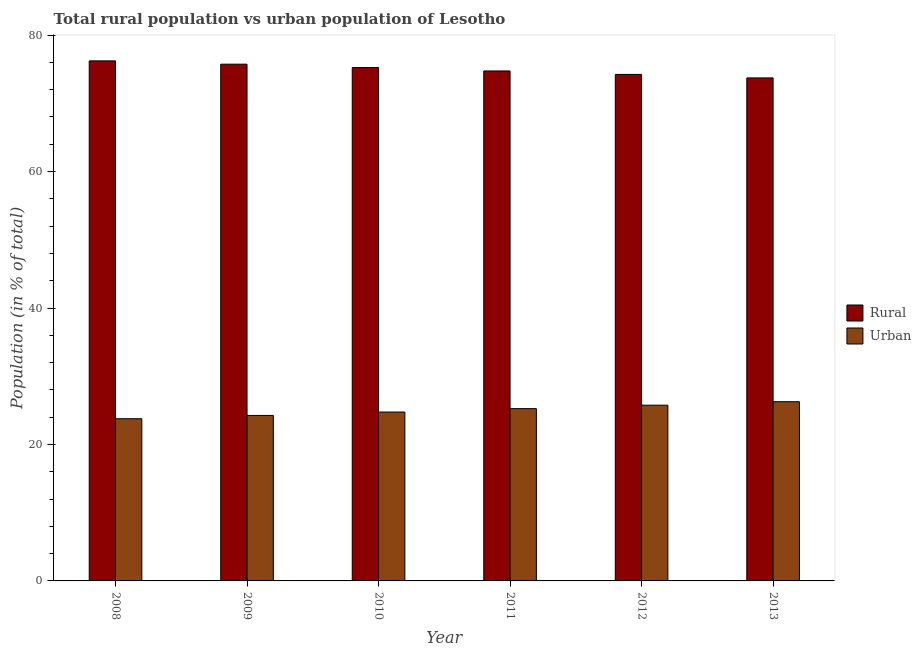How many different coloured bars are there?
Your answer should be very brief. 2. Are the number of bars per tick equal to the number of legend labels?
Your answer should be compact. Yes. How many bars are there on the 1st tick from the left?
Give a very brief answer. 2. What is the label of the 1st group of bars from the left?
Your answer should be compact. 2008. In how many cases, is the number of bars for a given year not equal to the number of legend labels?
Provide a short and direct response. 0. What is the urban population in 2009?
Your response must be concise. 24.26. Across all years, what is the maximum urban population?
Your answer should be very brief. 26.27. Across all years, what is the minimum urban population?
Make the answer very short. 23.77. In which year was the urban population minimum?
Make the answer very short. 2008. What is the total urban population in the graph?
Provide a short and direct response. 150.07. What is the difference between the rural population in 2008 and that in 2013?
Provide a succinct answer. 2.5. What is the difference between the rural population in 2010 and the urban population in 2009?
Offer a very short reply. -0.49. What is the average urban population per year?
Your answer should be compact. 25.01. In the year 2012, what is the difference between the rural population and urban population?
Your answer should be very brief. 0. What is the ratio of the rural population in 2011 to that in 2013?
Offer a very short reply. 1.01. Is the urban population in 2009 less than that in 2011?
Your answer should be very brief. Yes. Is the difference between the urban population in 2009 and 2013 greater than the difference between the rural population in 2009 and 2013?
Provide a succinct answer. No. What is the difference between the highest and the second highest rural population?
Keep it short and to the point. 0.48. What is the difference between the highest and the lowest urban population?
Your response must be concise. 2.5. What does the 1st bar from the left in 2013 represents?
Provide a succinct answer. Rural. What does the 2nd bar from the right in 2009 represents?
Offer a terse response. Rural. How many bars are there?
Keep it short and to the point. 12. How many years are there in the graph?
Provide a short and direct response. 6. What is the difference between two consecutive major ticks on the Y-axis?
Provide a short and direct response. 20. Are the values on the major ticks of Y-axis written in scientific E-notation?
Your answer should be very brief. No. Does the graph contain any zero values?
Offer a terse response. No. Does the graph contain grids?
Provide a short and direct response. No. Where does the legend appear in the graph?
Give a very brief answer. Center right. How many legend labels are there?
Your response must be concise. 2. What is the title of the graph?
Offer a very short reply. Total rural population vs urban population of Lesotho. What is the label or title of the X-axis?
Offer a very short reply. Year. What is the label or title of the Y-axis?
Keep it short and to the point. Population (in % of total). What is the Population (in % of total) in Rural in 2008?
Offer a very short reply. 76.23. What is the Population (in % of total) in Urban in 2008?
Provide a short and direct response. 23.77. What is the Population (in % of total) of Rural in 2009?
Ensure brevity in your answer.  75.74. What is the Population (in % of total) of Urban in 2009?
Make the answer very short. 24.26. What is the Population (in % of total) of Rural in 2010?
Your response must be concise. 75.25. What is the Population (in % of total) of Urban in 2010?
Provide a short and direct response. 24.75. What is the Population (in % of total) of Rural in 2011?
Give a very brief answer. 74.75. What is the Population (in % of total) of Urban in 2011?
Give a very brief answer. 25.25. What is the Population (in % of total) in Rural in 2012?
Give a very brief answer. 74.24. What is the Population (in % of total) of Urban in 2012?
Provide a succinct answer. 25.76. What is the Population (in % of total) in Rural in 2013?
Give a very brief answer. 73.73. What is the Population (in % of total) in Urban in 2013?
Ensure brevity in your answer.  26.27. Across all years, what is the maximum Population (in % of total) in Rural?
Offer a very short reply. 76.23. Across all years, what is the maximum Population (in % of total) in Urban?
Offer a terse response. 26.27. Across all years, what is the minimum Population (in % of total) of Rural?
Your answer should be very brief. 73.73. Across all years, what is the minimum Population (in % of total) in Urban?
Your answer should be compact. 23.77. What is the total Population (in % of total) of Rural in the graph?
Offer a very short reply. 449.93. What is the total Population (in % of total) of Urban in the graph?
Your answer should be very brief. 150.07. What is the difference between the Population (in % of total) of Rural in 2008 and that in 2009?
Offer a very short reply. 0.48. What is the difference between the Population (in % of total) of Urban in 2008 and that in 2009?
Your response must be concise. -0.48. What is the difference between the Population (in % of total) of Urban in 2008 and that in 2010?
Provide a short and direct response. -0.98. What is the difference between the Population (in % of total) in Rural in 2008 and that in 2011?
Ensure brevity in your answer.  1.48. What is the difference between the Population (in % of total) in Urban in 2008 and that in 2011?
Provide a short and direct response. -1.48. What is the difference between the Population (in % of total) in Rural in 2008 and that in 2012?
Provide a succinct answer. 1.99. What is the difference between the Population (in % of total) of Urban in 2008 and that in 2012?
Offer a very short reply. -1.99. What is the difference between the Population (in % of total) of Rural in 2008 and that in 2013?
Ensure brevity in your answer.  2.5. What is the difference between the Population (in % of total) in Urban in 2008 and that in 2013?
Provide a succinct answer. -2.5. What is the difference between the Population (in % of total) in Rural in 2009 and that in 2010?
Make the answer very short. 0.49. What is the difference between the Population (in % of total) of Urban in 2009 and that in 2010?
Make the answer very short. -0.49. What is the difference between the Population (in % of total) of Urban in 2009 and that in 2011?
Offer a terse response. -0.99. What is the difference between the Population (in % of total) in Rural in 2009 and that in 2012?
Give a very brief answer. 1.5. What is the difference between the Population (in % of total) in Urban in 2009 and that in 2012?
Offer a terse response. -1.5. What is the difference between the Population (in % of total) of Rural in 2009 and that in 2013?
Your answer should be very brief. 2.01. What is the difference between the Population (in % of total) in Urban in 2009 and that in 2013?
Your answer should be very brief. -2.01. What is the difference between the Population (in % of total) of Rural in 2010 and that in 2011?
Provide a short and direct response. 0.5. What is the difference between the Population (in % of total) of Urban in 2010 and that in 2011?
Ensure brevity in your answer.  -0.5. What is the difference between the Population (in % of total) of Urban in 2010 and that in 2012?
Provide a succinct answer. -1.01. What is the difference between the Population (in % of total) in Rural in 2010 and that in 2013?
Keep it short and to the point. 1.52. What is the difference between the Population (in % of total) in Urban in 2010 and that in 2013?
Your answer should be compact. -1.52. What is the difference between the Population (in % of total) of Rural in 2011 and that in 2012?
Offer a terse response. 0.51. What is the difference between the Population (in % of total) in Urban in 2011 and that in 2012?
Give a very brief answer. -0.51. What is the difference between the Population (in % of total) in Urban in 2011 and that in 2013?
Your response must be concise. -1.02. What is the difference between the Population (in % of total) of Rural in 2012 and that in 2013?
Your answer should be very brief. 0.51. What is the difference between the Population (in % of total) of Urban in 2012 and that in 2013?
Ensure brevity in your answer.  -0.51. What is the difference between the Population (in % of total) of Rural in 2008 and the Population (in % of total) of Urban in 2009?
Make the answer very short. 51.97. What is the difference between the Population (in % of total) of Rural in 2008 and the Population (in % of total) of Urban in 2010?
Offer a terse response. 51.47. What is the difference between the Population (in % of total) of Rural in 2008 and the Population (in % of total) of Urban in 2011?
Provide a short and direct response. 50.97. What is the difference between the Population (in % of total) in Rural in 2008 and the Population (in % of total) in Urban in 2012?
Provide a short and direct response. 50.47. What is the difference between the Population (in % of total) of Rural in 2008 and the Population (in % of total) of Urban in 2013?
Provide a short and direct response. 49.95. What is the difference between the Population (in % of total) of Rural in 2009 and the Population (in % of total) of Urban in 2010?
Offer a very short reply. 50.99. What is the difference between the Population (in % of total) of Rural in 2009 and the Population (in % of total) of Urban in 2011?
Keep it short and to the point. 50.49. What is the difference between the Population (in % of total) of Rural in 2009 and the Population (in % of total) of Urban in 2012?
Make the answer very short. 49.98. What is the difference between the Population (in % of total) in Rural in 2009 and the Population (in % of total) in Urban in 2013?
Your response must be concise. 49.47. What is the difference between the Population (in % of total) in Rural in 2010 and the Population (in % of total) in Urban in 2011?
Your response must be concise. 49.99. What is the difference between the Population (in % of total) of Rural in 2010 and the Population (in % of total) of Urban in 2012?
Offer a very short reply. 49.49. What is the difference between the Population (in % of total) in Rural in 2010 and the Population (in % of total) in Urban in 2013?
Give a very brief answer. 48.98. What is the difference between the Population (in % of total) in Rural in 2011 and the Population (in % of total) in Urban in 2012?
Keep it short and to the point. 48.99. What is the difference between the Population (in % of total) in Rural in 2011 and the Population (in % of total) in Urban in 2013?
Give a very brief answer. 48.48. What is the difference between the Population (in % of total) of Rural in 2012 and the Population (in % of total) of Urban in 2013?
Your answer should be compact. 47.97. What is the average Population (in % of total) of Rural per year?
Your answer should be compact. 74.99. What is the average Population (in % of total) of Urban per year?
Offer a terse response. 25.01. In the year 2008, what is the difference between the Population (in % of total) in Rural and Population (in % of total) in Urban?
Offer a terse response. 52.45. In the year 2009, what is the difference between the Population (in % of total) of Rural and Population (in % of total) of Urban?
Give a very brief answer. 51.48. In the year 2010, what is the difference between the Population (in % of total) in Rural and Population (in % of total) in Urban?
Keep it short and to the point. 50.49. In the year 2011, what is the difference between the Population (in % of total) in Rural and Population (in % of total) in Urban?
Ensure brevity in your answer.  49.49. In the year 2012, what is the difference between the Population (in % of total) of Rural and Population (in % of total) of Urban?
Offer a very short reply. 48.48. In the year 2013, what is the difference between the Population (in % of total) of Rural and Population (in % of total) of Urban?
Offer a terse response. 47.46. What is the ratio of the Population (in % of total) of Rural in 2008 to that in 2009?
Offer a terse response. 1.01. What is the ratio of the Population (in % of total) in Urban in 2008 to that in 2009?
Your answer should be very brief. 0.98. What is the ratio of the Population (in % of total) in Rural in 2008 to that in 2010?
Provide a short and direct response. 1.01. What is the ratio of the Population (in % of total) in Urban in 2008 to that in 2010?
Keep it short and to the point. 0.96. What is the ratio of the Population (in % of total) of Rural in 2008 to that in 2011?
Offer a very short reply. 1.02. What is the ratio of the Population (in % of total) of Urban in 2008 to that in 2011?
Give a very brief answer. 0.94. What is the ratio of the Population (in % of total) in Rural in 2008 to that in 2012?
Provide a short and direct response. 1.03. What is the ratio of the Population (in % of total) in Urban in 2008 to that in 2012?
Keep it short and to the point. 0.92. What is the ratio of the Population (in % of total) of Rural in 2008 to that in 2013?
Provide a succinct answer. 1.03. What is the ratio of the Population (in % of total) of Urban in 2008 to that in 2013?
Keep it short and to the point. 0.91. What is the ratio of the Population (in % of total) in Rural in 2009 to that in 2010?
Offer a terse response. 1.01. What is the ratio of the Population (in % of total) of Urban in 2009 to that in 2010?
Provide a short and direct response. 0.98. What is the ratio of the Population (in % of total) of Rural in 2009 to that in 2011?
Provide a succinct answer. 1.01. What is the ratio of the Population (in % of total) of Urban in 2009 to that in 2011?
Offer a terse response. 0.96. What is the ratio of the Population (in % of total) of Rural in 2009 to that in 2012?
Give a very brief answer. 1.02. What is the ratio of the Population (in % of total) in Urban in 2009 to that in 2012?
Offer a terse response. 0.94. What is the ratio of the Population (in % of total) in Rural in 2009 to that in 2013?
Offer a very short reply. 1.03. What is the ratio of the Population (in % of total) of Urban in 2009 to that in 2013?
Give a very brief answer. 0.92. What is the ratio of the Population (in % of total) in Urban in 2010 to that in 2011?
Keep it short and to the point. 0.98. What is the ratio of the Population (in % of total) in Rural in 2010 to that in 2012?
Keep it short and to the point. 1.01. What is the ratio of the Population (in % of total) of Urban in 2010 to that in 2012?
Keep it short and to the point. 0.96. What is the ratio of the Population (in % of total) in Rural in 2010 to that in 2013?
Offer a terse response. 1.02. What is the ratio of the Population (in % of total) of Urban in 2010 to that in 2013?
Offer a very short reply. 0.94. What is the ratio of the Population (in % of total) of Rural in 2011 to that in 2012?
Keep it short and to the point. 1.01. What is the ratio of the Population (in % of total) in Urban in 2011 to that in 2012?
Offer a terse response. 0.98. What is the ratio of the Population (in % of total) in Rural in 2011 to that in 2013?
Your response must be concise. 1.01. What is the ratio of the Population (in % of total) of Urban in 2011 to that in 2013?
Make the answer very short. 0.96. What is the ratio of the Population (in % of total) in Urban in 2012 to that in 2013?
Offer a very short reply. 0.98. What is the difference between the highest and the second highest Population (in % of total) in Rural?
Ensure brevity in your answer.  0.48. What is the difference between the highest and the second highest Population (in % of total) of Urban?
Make the answer very short. 0.51. What is the difference between the highest and the lowest Population (in % of total) in Rural?
Make the answer very short. 2.5. What is the difference between the highest and the lowest Population (in % of total) of Urban?
Offer a terse response. 2.5. 